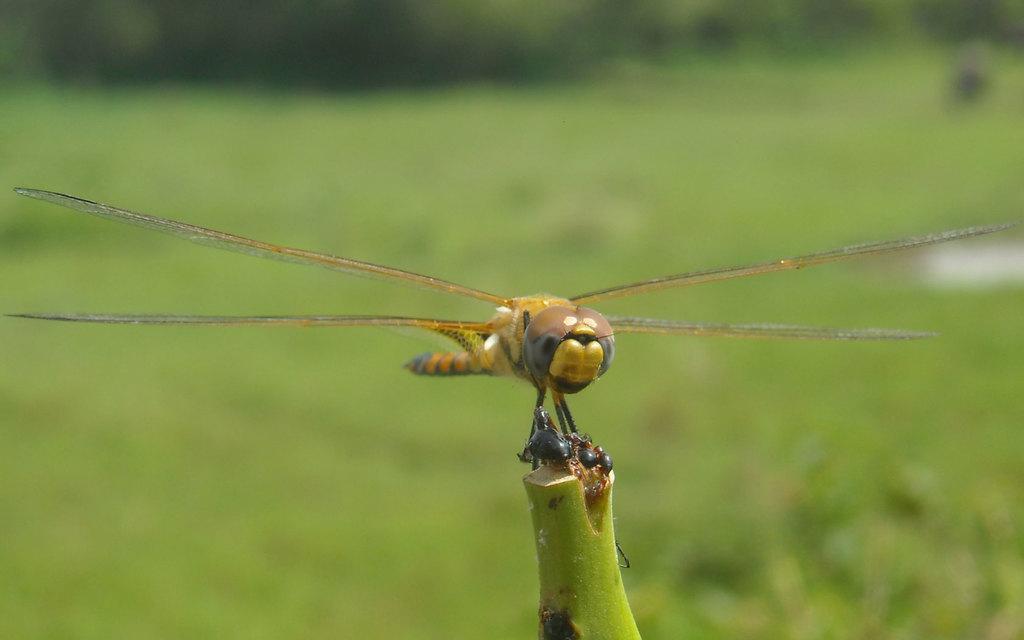Can you describe this image briefly? In this image I can see an insect on the plant. An insect is in brown and black color. And there is a blurred background. 